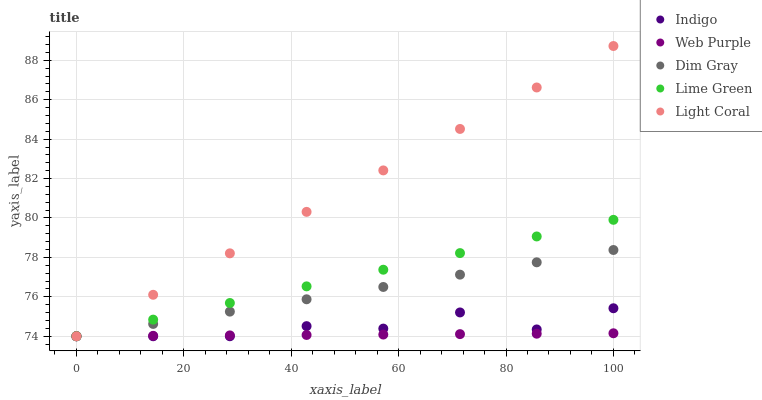Does Web Purple have the minimum area under the curve?
Answer yes or no. Yes. Does Light Coral have the maximum area under the curve?
Answer yes or no. Yes. Does Lime Green have the minimum area under the curve?
Answer yes or no. No. Does Lime Green have the maximum area under the curve?
Answer yes or no. No. Is Web Purple the smoothest?
Answer yes or no. Yes. Is Indigo the roughest?
Answer yes or no. Yes. Is Lime Green the smoothest?
Answer yes or no. No. Is Lime Green the roughest?
Answer yes or no. No. Does Light Coral have the lowest value?
Answer yes or no. Yes. Does Light Coral have the highest value?
Answer yes or no. Yes. Does Lime Green have the highest value?
Answer yes or no. No. Does Dim Gray intersect Light Coral?
Answer yes or no. Yes. Is Dim Gray less than Light Coral?
Answer yes or no. No. Is Dim Gray greater than Light Coral?
Answer yes or no. No. 